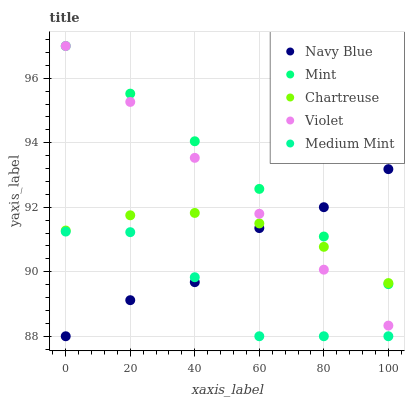Does Medium Mint have the minimum area under the curve?
Answer yes or no. Yes. Does Mint have the maximum area under the curve?
Answer yes or no. Yes. Does Navy Blue have the minimum area under the curve?
Answer yes or no. No. Does Navy Blue have the maximum area under the curve?
Answer yes or no. No. Is Mint the smoothest?
Answer yes or no. Yes. Is Medium Mint the roughest?
Answer yes or no. Yes. Is Navy Blue the smoothest?
Answer yes or no. No. Is Navy Blue the roughest?
Answer yes or no. No. Does Medium Mint have the lowest value?
Answer yes or no. Yes. Does Chartreuse have the lowest value?
Answer yes or no. No. Does Violet have the highest value?
Answer yes or no. Yes. Does Navy Blue have the highest value?
Answer yes or no. No. Is Medium Mint less than Violet?
Answer yes or no. Yes. Is Chartreuse greater than Medium Mint?
Answer yes or no. Yes. Does Mint intersect Violet?
Answer yes or no. Yes. Is Mint less than Violet?
Answer yes or no. No. Is Mint greater than Violet?
Answer yes or no. No. Does Medium Mint intersect Violet?
Answer yes or no. No. 